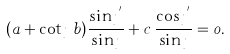Convert formula to latex. <formula><loc_0><loc_0><loc_500><loc_500>( a + \cot \eta \, b ) \frac { \sin \eta ^ { ^ { \prime } } } { \sin \eta } + c \, \frac { \cos \eta ^ { ^ { \prime } } } { \sin \eta } = 0 .</formula> 